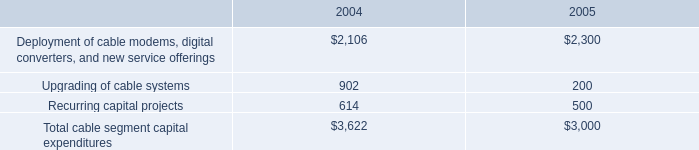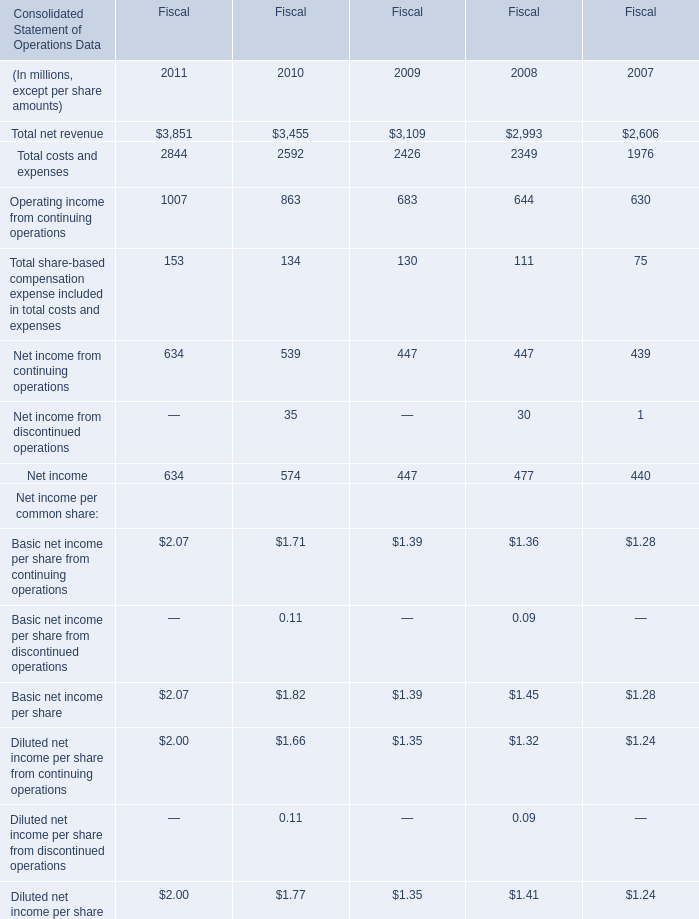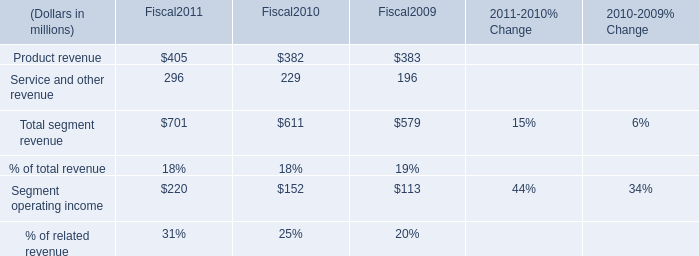What is the increasing rate of Net income from continuing operations between Fiscal 2009 and Fiscal 2010? 
Computations: ((539 - 447) / 447)
Answer: 0.20582. 